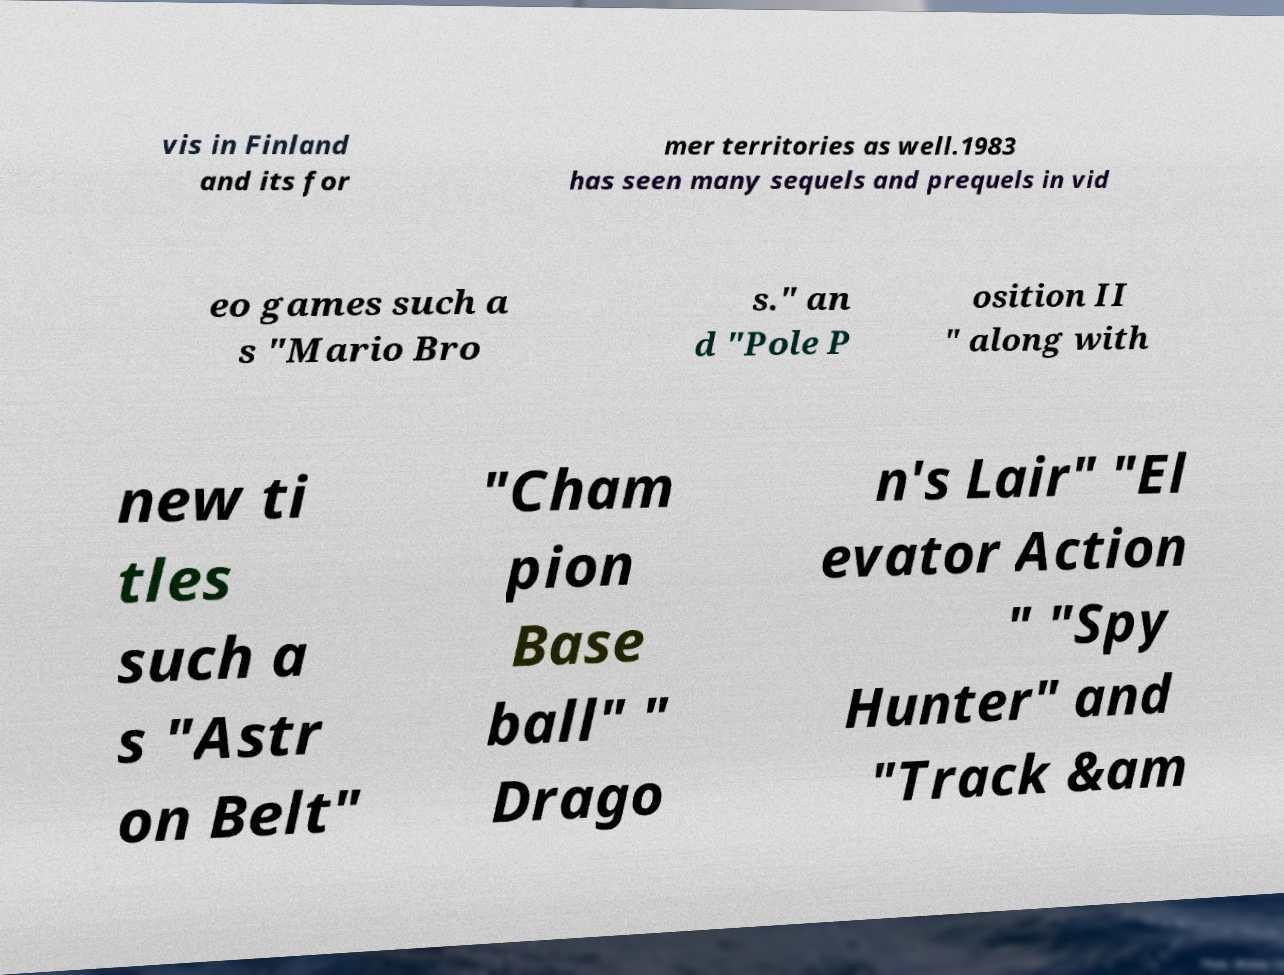For documentation purposes, I need the text within this image transcribed. Could you provide that? vis in Finland and its for mer territories as well.1983 has seen many sequels and prequels in vid eo games such a s "Mario Bro s." an d "Pole P osition II " along with new ti tles such a s "Astr on Belt" "Cham pion Base ball" " Drago n's Lair" "El evator Action " "Spy Hunter" and "Track &am 